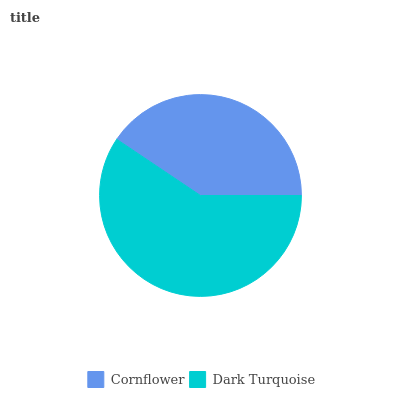Is Cornflower the minimum?
Answer yes or no. Yes. Is Dark Turquoise the maximum?
Answer yes or no. Yes. Is Dark Turquoise the minimum?
Answer yes or no. No. Is Dark Turquoise greater than Cornflower?
Answer yes or no. Yes. Is Cornflower less than Dark Turquoise?
Answer yes or no. Yes. Is Cornflower greater than Dark Turquoise?
Answer yes or no. No. Is Dark Turquoise less than Cornflower?
Answer yes or no. No. Is Dark Turquoise the high median?
Answer yes or no. Yes. Is Cornflower the low median?
Answer yes or no. Yes. Is Cornflower the high median?
Answer yes or no. No. Is Dark Turquoise the low median?
Answer yes or no. No. 